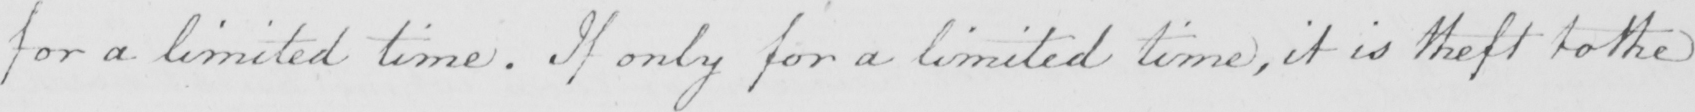Please transcribe the handwritten text in this image. for a limited time . If only for a limited time , it is theft to the 